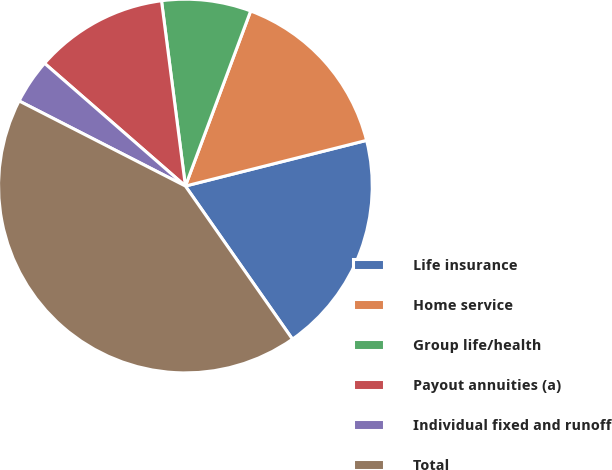Convert chart. <chart><loc_0><loc_0><loc_500><loc_500><pie_chart><fcel>Life insurance<fcel>Home service<fcel>Group life/health<fcel>Payout annuities (a)<fcel>Individual fixed and runoff<fcel>Total<nl><fcel>19.22%<fcel>15.39%<fcel>7.72%<fcel>11.55%<fcel>3.88%<fcel>42.24%<nl></chart> 